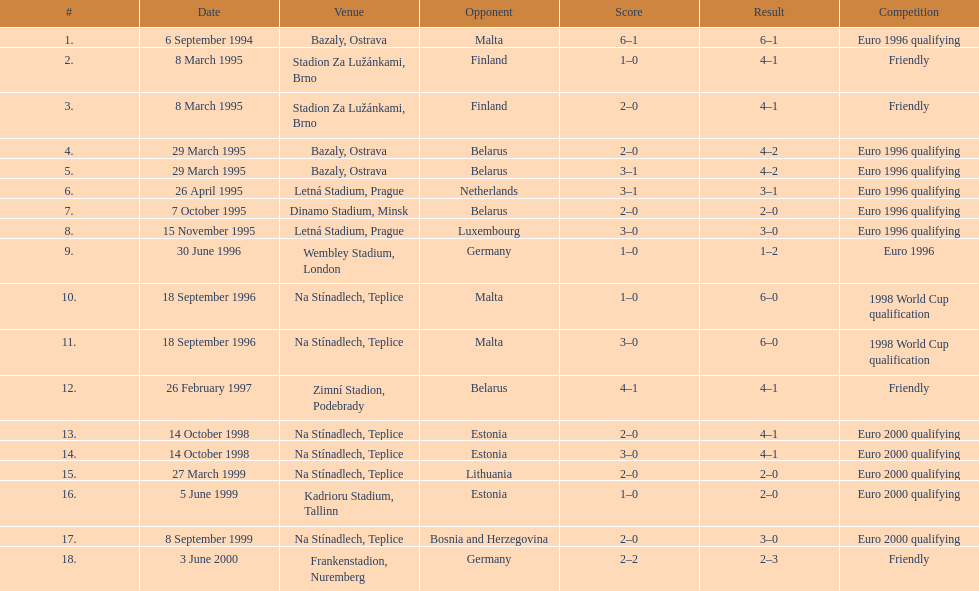How many games took place in ostrava? 2. 